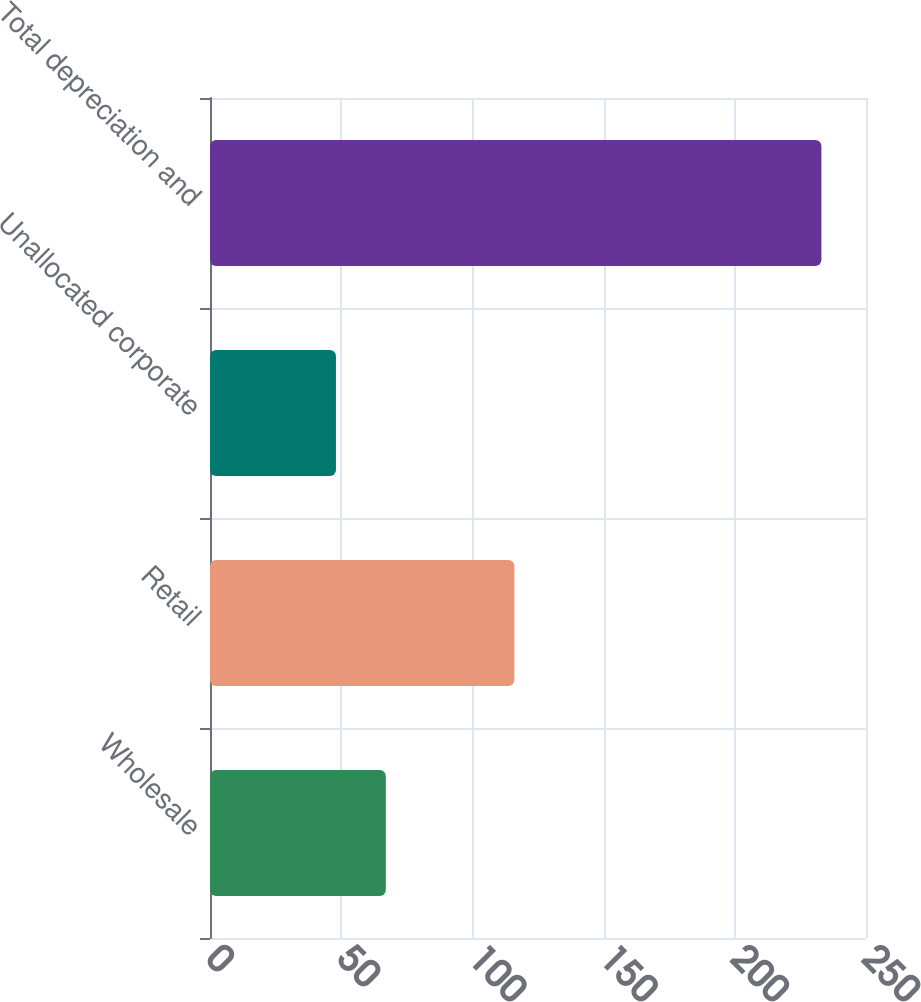<chart> <loc_0><loc_0><loc_500><loc_500><bar_chart><fcel>Wholesale<fcel>Retail<fcel>Unallocated corporate<fcel>Total depreciation and<nl><fcel>67<fcel>116<fcel>48<fcel>233<nl></chart> 